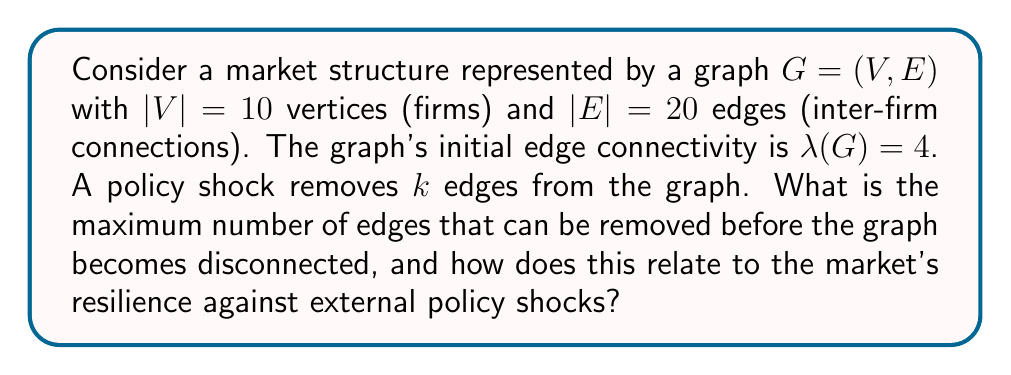Give your solution to this math problem. To solve this problem, we need to understand the concept of edge connectivity in graph theory and its relation to market resilience:

1. Edge connectivity $\lambda(G)$ is the minimum number of edges whose removal disconnects the graph.

2. In this case, $\lambda(G)=4$, meaning the graph will remain connected as long as fewer than 4 edges are removed.

3. The maximum number of edges that can be removed before the graph becomes disconnected is $\lambda(G) - 1 = 4 - 1 = 3$.

4. This number represents the market's resilience against policy shocks. The higher this number, the more robust the market structure is against external disruptions.

5. We can calculate the resilience ratio as:

   $$\text{Resilience Ratio} = \frac{\text{Max edges removable}}{\text{Total edges}} = \frac{3}{20} = 0.15 \text{ or } 15\%$$

6. This ratio indicates that the market can withstand the removal of up to 15% of its inter-firm connections before becoming structurally compromised.

7. From the perspective of a critic focusing on external factors, this result suggests that while the market has some resilience, it's still vulnerable to significant policy shocks that could disrupt more than 15% of inter-firm connections.

8. The relatively low resilience ratio (15%) supports the critic's view that external factors like government policies can have a substantial impact on market structures.
Answer: The maximum number of edges that can be removed before the graph becomes disconnected is 3. This represents a resilience ratio of 15%, indicating moderate vulnerability to external policy shocks and supporting the critic's perspective on the influence of external factors on market trends. 